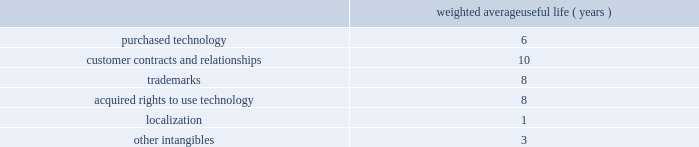Adobe systems incorporated notes to consolidated financial statements ( continued ) we review our goodwill for impairment annually , or more frequently , if facts and circumstances warrant a review .
We completed our annual impairment test in the second quarter of fiscal 2013 .
We elected to use the step 1 quantitative assessment for our three reporting units 2014digital media , digital marketing and print and publishing 2014and determined that there was no impairment of goodwill .
There is no significant risk of material goodwill impairment in any of our reporting units , based upon the results of our annual goodwill impairment test .
We amortize intangible assets with finite lives over their estimated useful lives and review them for impairment whenever an impairment indicator exists .
We continually monitor events and changes in circumstances that could indicate carrying amounts of our long-lived assets , including our intangible assets may not be recoverable .
When such events or changes in circumstances occur , we assess recoverability by determining whether the carrying value of such assets will be recovered through the undiscounted expected future cash flows .
If the future undiscounted cash flows are less than the carrying amount of these assets , we recognize an impairment loss based on any excess of the carrying amount over the fair value of the assets .
We did not recognize any intangible asset impairment charges in fiscal 2013 , 2012 or 2011 .
Our intangible assets are amortized over their estimated useful lives of 1 to 14 years .
Amortization is based on the pattern in which the economic benefits of the intangible asset will be consumed or on a straight-line basis when the consumption pattern is not apparent .
The weighted average useful lives of our intangible assets were as follows : weighted average useful life ( years ) .
Software development costs capitalization of software development costs for software to be sold , leased , or otherwise marketed begins upon the establishment of technological feasibility , which is generally the completion of a working prototype that has been certified as having no critical bugs and is a release candidate .
Amortization begins once the software is ready for its intended use , generally based on the pattern in which the economic benefits will be consumed .
To date , software development costs incurred between completion of a working prototype and general availability of the related product have not been material .
Internal use software we capitalize costs associated with customized internal-use software systems that have reached the application development stage .
Such capitalized costs include external direct costs utilized in developing or obtaining the applications and payroll and payroll-related expenses for employees , who are directly associated with the development of the applications .
Capitalization of such costs begins when the preliminary project stage is complete and ceases at the point in which the project is substantially complete and is ready for its intended purpose .
Income taxes we use the asset and liability method of accounting for income taxes .
Under this method , income tax expense is recognized for the amount of taxes payable or refundable for the current year .
In addition , deferred tax assets and liabilities are recognized for expected future tax consequences of temporary differences between the financial reporting and tax bases of assets and liabilities , and for operating losses and tax credit carryforwards .
We record a valuation allowance to reduce deferred tax assets to an amount for which realization is more likely than not. .
What is the yearly amortization rate related to purchased technology? 
Computations: (100 / 6)
Answer: 16.66667. Adobe systems incorporated notes to consolidated financial statements ( continued ) we review our goodwill for impairment annually , or more frequently , if facts and circumstances warrant a review .
We completed our annual impairment test in the second quarter of fiscal 2013 .
We elected to use the step 1 quantitative assessment for our three reporting units 2014digital media , digital marketing and print and publishing 2014and determined that there was no impairment of goodwill .
There is no significant risk of material goodwill impairment in any of our reporting units , based upon the results of our annual goodwill impairment test .
We amortize intangible assets with finite lives over their estimated useful lives and review them for impairment whenever an impairment indicator exists .
We continually monitor events and changes in circumstances that could indicate carrying amounts of our long-lived assets , including our intangible assets may not be recoverable .
When such events or changes in circumstances occur , we assess recoverability by determining whether the carrying value of such assets will be recovered through the undiscounted expected future cash flows .
If the future undiscounted cash flows are less than the carrying amount of these assets , we recognize an impairment loss based on any excess of the carrying amount over the fair value of the assets .
We did not recognize any intangible asset impairment charges in fiscal 2013 , 2012 or 2011 .
Our intangible assets are amortized over their estimated useful lives of 1 to 14 years .
Amortization is based on the pattern in which the economic benefits of the intangible asset will be consumed or on a straight-line basis when the consumption pattern is not apparent .
The weighted average useful lives of our intangible assets were as follows : weighted average useful life ( years ) .
Software development costs capitalization of software development costs for software to be sold , leased , or otherwise marketed begins upon the establishment of technological feasibility , which is generally the completion of a working prototype that has been certified as having no critical bugs and is a release candidate .
Amortization begins once the software is ready for its intended use , generally based on the pattern in which the economic benefits will be consumed .
To date , software development costs incurred between completion of a working prototype and general availability of the related product have not been material .
Internal use software we capitalize costs associated with customized internal-use software systems that have reached the application development stage .
Such capitalized costs include external direct costs utilized in developing or obtaining the applications and payroll and payroll-related expenses for employees , who are directly associated with the development of the applications .
Capitalization of such costs begins when the preliminary project stage is complete and ceases at the point in which the project is substantially complete and is ready for its intended purpose .
Income taxes we use the asset and liability method of accounting for income taxes .
Under this method , income tax expense is recognized for the amount of taxes payable or refundable for the current year .
In addition , deferred tax assets and liabilities are recognized for expected future tax consequences of temporary differences between the financial reporting and tax bases of assets and liabilities , and for operating losses and tax credit carryforwards .
We record a valuation allowance to reduce deferred tax assets to an amount for which realization is more likely than not. .
What is the yearly amortization rate related to trademarks? 
Computations: (100 - 8)
Answer: 92.0. Adobe systems incorporated notes to consolidated financial statements ( continued ) we review our goodwill for impairment annually , or more frequently , if facts and circumstances warrant a review .
We completed our annual impairment test in the second quarter of fiscal 2013 .
We elected to use the step 1 quantitative assessment for our three reporting units 2014digital media , digital marketing and print and publishing 2014and determined that there was no impairment of goodwill .
There is no significant risk of material goodwill impairment in any of our reporting units , based upon the results of our annual goodwill impairment test .
We amortize intangible assets with finite lives over their estimated useful lives and review them for impairment whenever an impairment indicator exists .
We continually monitor events and changes in circumstances that could indicate carrying amounts of our long-lived assets , including our intangible assets may not be recoverable .
When such events or changes in circumstances occur , we assess recoverability by determining whether the carrying value of such assets will be recovered through the undiscounted expected future cash flows .
If the future undiscounted cash flows are less than the carrying amount of these assets , we recognize an impairment loss based on any excess of the carrying amount over the fair value of the assets .
We did not recognize any intangible asset impairment charges in fiscal 2013 , 2012 or 2011 .
Our intangible assets are amortized over their estimated useful lives of 1 to 14 years .
Amortization is based on the pattern in which the economic benefits of the intangible asset will be consumed or on a straight-line basis when the consumption pattern is not apparent .
The weighted average useful lives of our intangible assets were as follows : weighted average useful life ( years ) .
Software development costs capitalization of software development costs for software to be sold , leased , or otherwise marketed begins upon the establishment of technological feasibility , which is generally the completion of a working prototype that has been certified as having no critical bugs and is a release candidate .
Amortization begins once the software is ready for its intended use , generally based on the pattern in which the economic benefits will be consumed .
To date , software development costs incurred between completion of a working prototype and general availability of the related product have not been material .
Internal use software we capitalize costs associated with customized internal-use software systems that have reached the application development stage .
Such capitalized costs include external direct costs utilized in developing or obtaining the applications and payroll and payroll-related expenses for employees , who are directly associated with the development of the applications .
Capitalization of such costs begins when the preliminary project stage is complete and ceases at the point in which the project is substantially complete and is ready for its intended purpose .
Income taxes we use the asset and liability method of accounting for income taxes .
Under this method , income tax expense is recognized for the amount of taxes payable or refundable for the current year .
In addition , deferred tax assets and liabilities are recognized for expected future tax consequences of temporary differences between the financial reporting and tax bases of assets and liabilities , and for operating losses and tax credit carryforwards .
We record a valuation allowance to reduce deferred tax assets to an amount for which realization is more likely than not. .
What is the average weighted average useful life ( years ) for trademarks and acquired rights to use technology? 
Computations: ((8 + 8) / 2)
Answer: 8.0. Adobe systems incorporated notes to consolidated financial statements ( continued ) we review our goodwill for impairment annually , or more frequently , if facts and circumstances warrant a review .
We completed our annual impairment test in the second quarter of fiscal 2014 .
We elected to use the step 1 quantitative assessment for our reporting units and determined that there was no impairment of goodwill .
There is no significant risk of material goodwill impairment in any of our reporting units , based upon the results of our annual goodwill impairment test .
We amortize intangible assets with finite lives over their estimated useful lives and review them for impairment whenever an impairment indicator exists .
We continually monitor events and changes in circumstances that could indicate carrying amounts of our long-lived assets , including our intangible assets may not be recoverable .
When such events or changes in circumstances occur , we assess recoverability by determining whether the carrying value of such assets will be recovered through the undiscounted expected future cash flows .
If the future undiscounted cash flows are less than the carrying amount of these assets , we recognize an impairment loss based on any excess of the carrying amount over the fair value of the assets .
We did not recognize any intangible asset impairment charges in fiscal 2014 , 2013 or 2012 .
Our intangible assets are amortized over their estimated useful lives of 1 to 14 years .
Amortization is based on the pattern in which the economic benefits of the intangible asset will be consumed or on a straight-line basis when the consumption pattern is not apparent .
The weighted average useful lives of our intangible assets were as follows : weighted average useful life ( years ) .
Software development costs capitalization of software development costs for software to be sold , leased , or otherwise marketed begins upon the establishment of technological feasibility , which is generally the completion of a working prototype that has been certified as having no critical bugs and is a release candidate .
Amortization begins once the software is ready for its intended use , generally based on the pattern in which the economic benefits will be consumed .
To date , software development costs incurred between completion of a working prototype and general availability of the related product have not been material .
Internal use software we capitalize costs associated with customized internal-use software systems that have reached the application development stage .
Such capitalized costs include external direct costs utilized in developing or obtaining the applications and payroll and payroll-related expenses for employees , who are directly associated with the development of the applications .
Capitalization of such costs begins when the preliminary project stage is complete and ceases at the point in which the project is substantially complete and is ready for its intended purpose .
Income taxes we use the asset and liability method of accounting for income taxes .
Under this method , income tax expense is recognized for the amount of taxes payable or refundable for the current year .
In addition , deferred tax assets and liabilities are recognized for expected future tax consequences of temporary differences between the financial reporting and tax bases of assets and liabilities , and for operating losses and tax credit carryforwards .
We record a valuation allowance to reduce deferred tax assets to an amount for which realization is more likely than not .
Taxes collected from customers we net taxes collected from customers against those remitted to government authorities in our financial statements .
Accordingly , taxes collected from customers are not reported as revenue. .
What is the yearly amortization rate related to the trademarks? 
Computations: (100 / 8)
Answer: 12.5. 